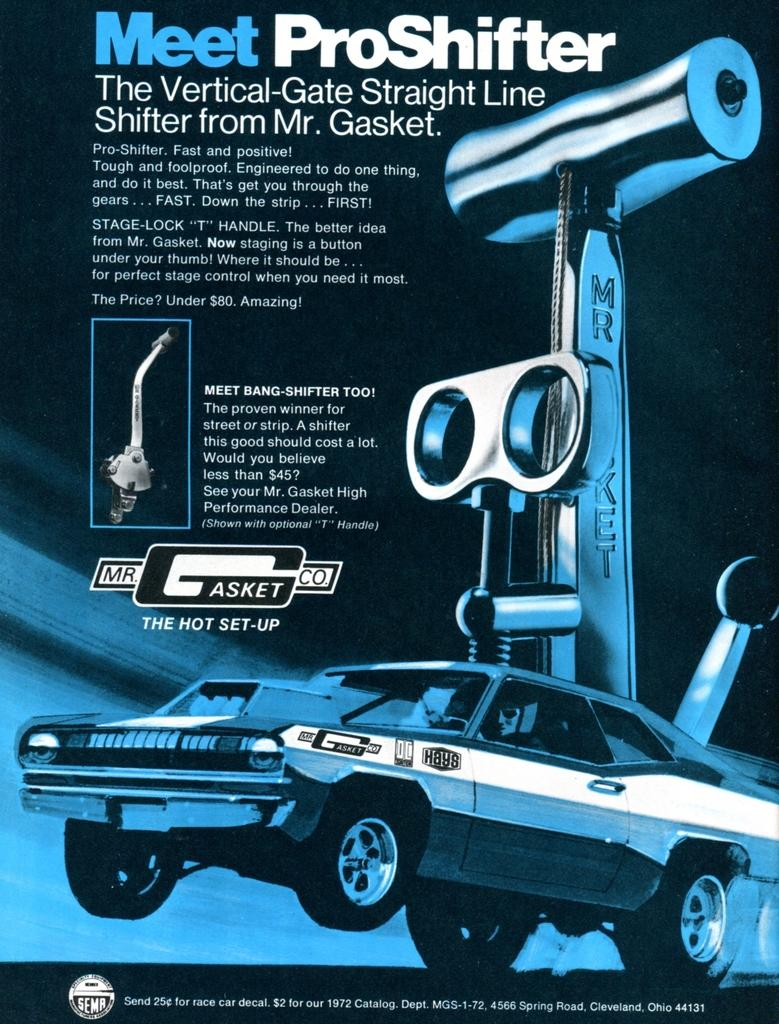What is present on the poster in the image? There is a poster in the image that contains text and images. What type of images can be seen on the poster? The poster contains an image of a car and an image of a machine. Can you see a stamp on the poster in the image? There is no stamp present on the poster in the image. Is there a stream visible in the image? There is no stream present in the image; the focus is on the poster. 